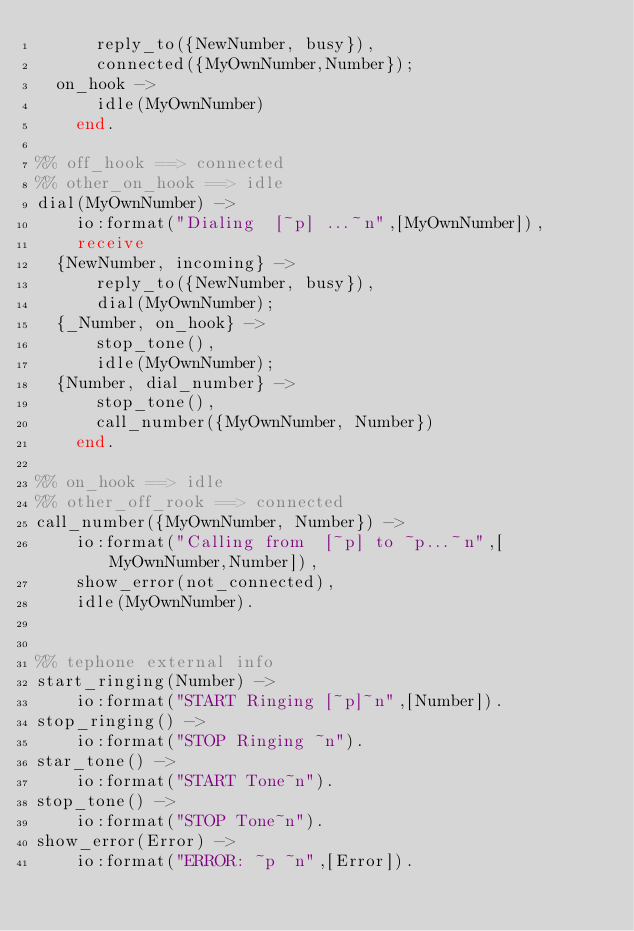Convert code to text. <code><loc_0><loc_0><loc_500><loc_500><_Erlang_>	    reply_to({NewNumber, busy}),
	    connected({MyOwnNumber,Number});
	on_hook ->
	    idle(MyOwnNumber)
    end.

%% off_hook ==> connected
%% other_on_hook ==> idle
dial(MyOwnNumber) ->
    io:format("Dialing  [~p] ...~n",[MyOwnNumber]),
    receive
	{NewNumber, incoming} ->
	    reply_to({NewNumber, busy}),
	    dial(MyOwnNumber);
	{_Number, on_hook} ->
	    stop_tone(),
	    idle(MyOwnNumber);
	{Number, dial_number} ->
	    stop_tone(),
	    call_number({MyOwnNumber, Number})
    end.

%% on_hook ==> idle
%% other_off_rook ==> connected
call_number({MyOwnNumber, Number}) ->
    io:format("Calling from  [~p] to ~p...~n",[MyOwnNumber,Number]),
    show_error(not_connected),
    idle(MyOwnNumber).


%% tephone external info
start_ringing(Number) ->
    io:format("START Ringing [~p]~n",[Number]).
stop_ringing() ->
    io:format("STOP Ringing ~n").
star_tone() ->
    io:format("START Tone~n").
stop_tone() ->
    io:format("STOP Tone~n").
show_error(Error) ->
    io:format("ERROR: ~p ~n",[Error]).

</code> 